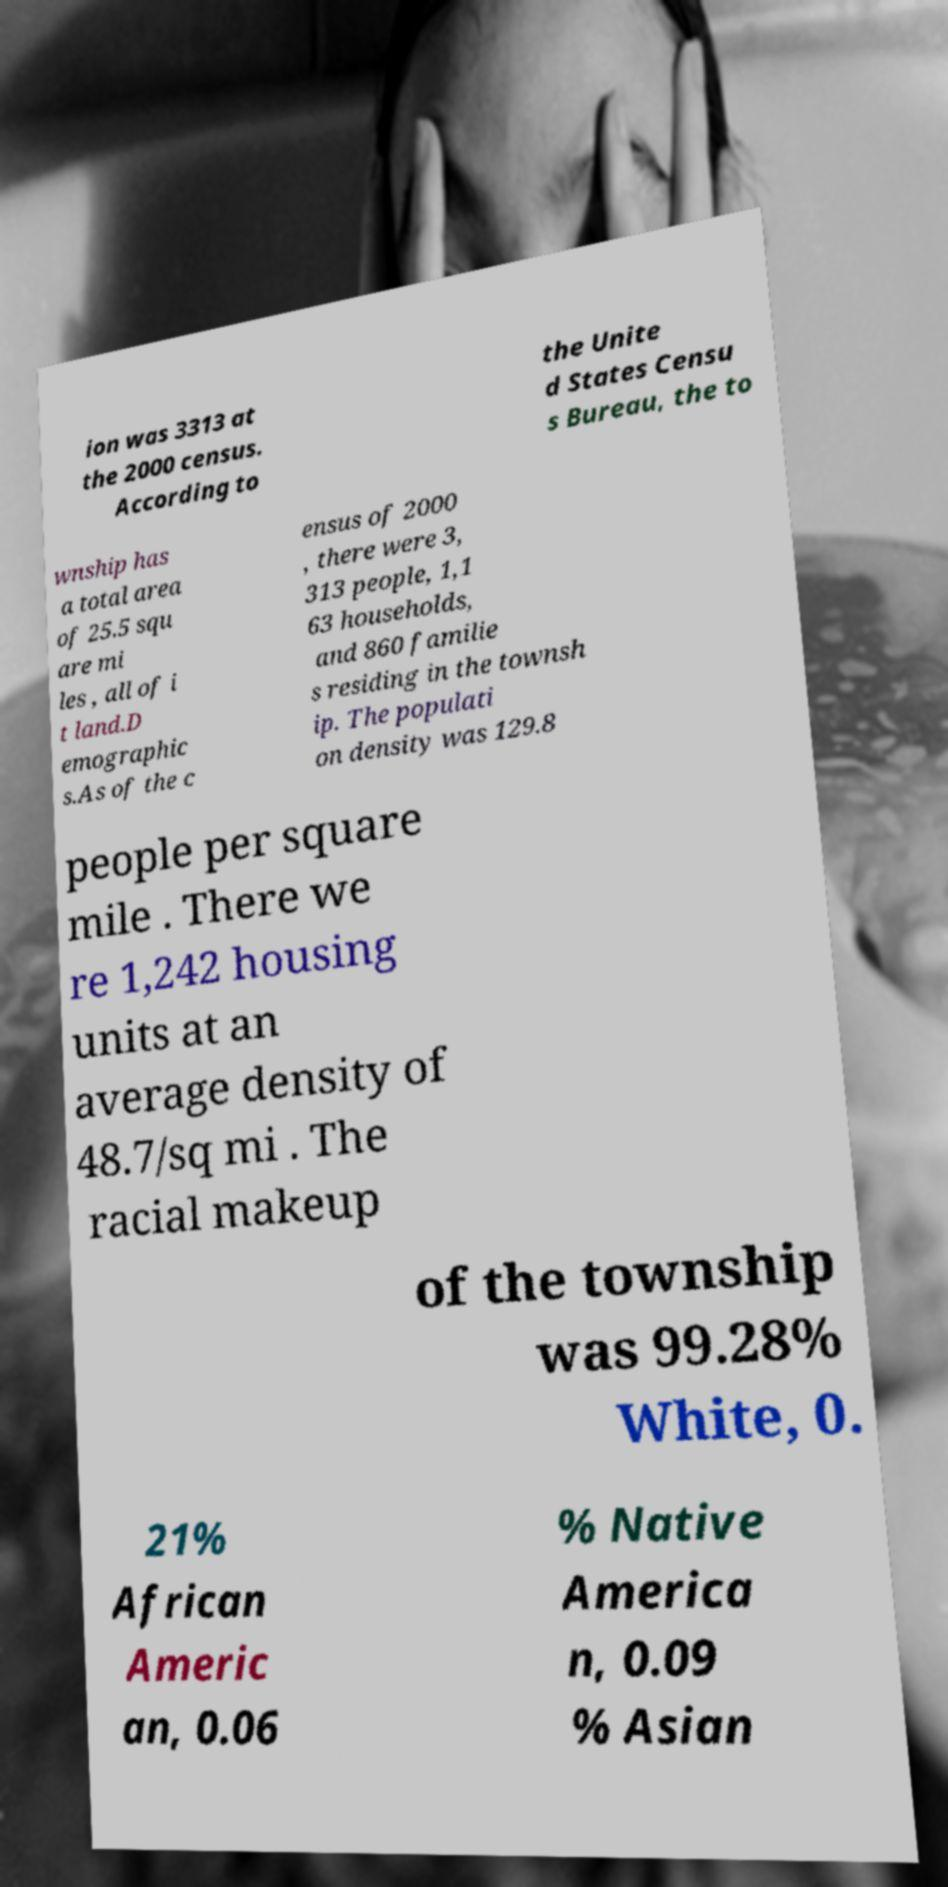What messages or text are displayed in this image? I need them in a readable, typed format. ion was 3313 at the 2000 census. According to the Unite d States Censu s Bureau, the to wnship has a total area of 25.5 squ are mi les , all of i t land.D emographic s.As of the c ensus of 2000 , there were 3, 313 people, 1,1 63 households, and 860 familie s residing in the townsh ip. The populati on density was 129.8 people per square mile . There we re 1,242 housing units at an average density of 48.7/sq mi . The racial makeup of the township was 99.28% White, 0. 21% African Americ an, 0.06 % Native America n, 0.09 % Asian 